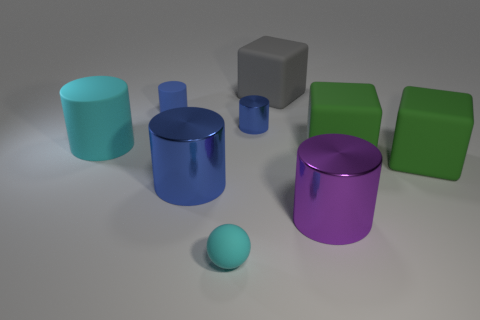How many blue cylinders must be subtracted to get 1 blue cylinders? 2 Subtract all red spheres. How many blue cylinders are left? 3 Subtract 2 cylinders. How many cylinders are left? 3 Subtract all cyan cylinders. How many cylinders are left? 4 Subtract all large rubber cylinders. How many cylinders are left? 4 Subtract all yellow cylinders. Subtract all gray blocks. How many cylinders are left? 5 Add 1 big cylinders. How many objects exist? 10 Subtract all balls. How many objects are left? 8 Add 6 purple metallic cylinders. How many purple metallic cylinders are left? 7 Add 4 cyan cylinders. How many cyan cylinders exist? 5 